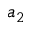<formula> <loc_0><loc_0><loc_500><loc_500>a _ { 2 }</formula> 